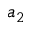<formula> <loc_0><loc_0><loc_500><loc_500>a _ { 2 }</formula> 